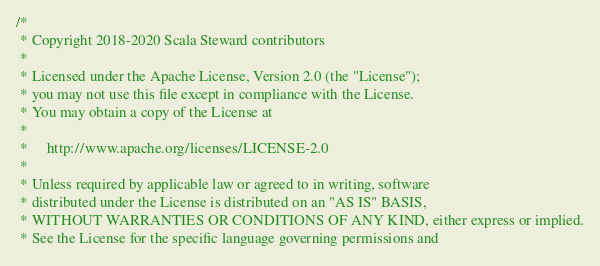Convert code to text. <code><loc_0><loc_0><loc_500><loc_500><_Scala_>/*
 * Copyright 2018-2020 Scala Steward contributors
 *
 * Licensed under the Apache License, Version 2.0 (the "License");
 * you may not use this file except in compliance with the License.
 * You may obtain a copy of the License at
 *
 *     http://www.apache.org/licenses/LICENSE-2.0
 *
 * Unless required by applicable law or agreed to in writing, software
 * distributed under the License is distributed on an "AS IS" BASIS,
 * WITHOUT WARRANTIES OR CONDITIONS OF ANY KIND, either express or implied.
 * See the License for the specific language governing permissions and</code> 